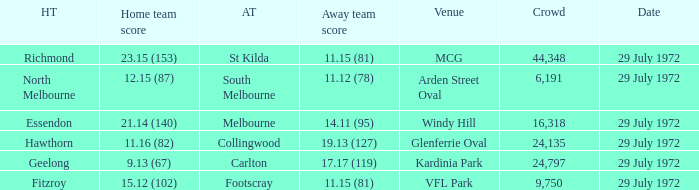What was the largest crowd size at arden street oval? 6191.0. 